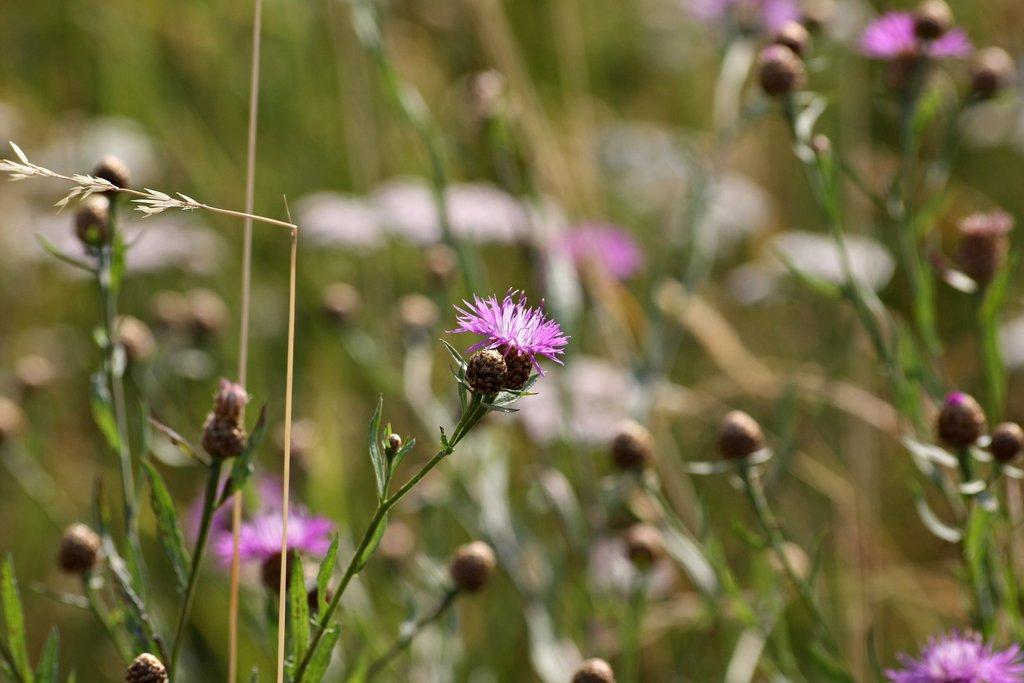How would you summarize this image in a sentence or two? In the image there are flower plants. 